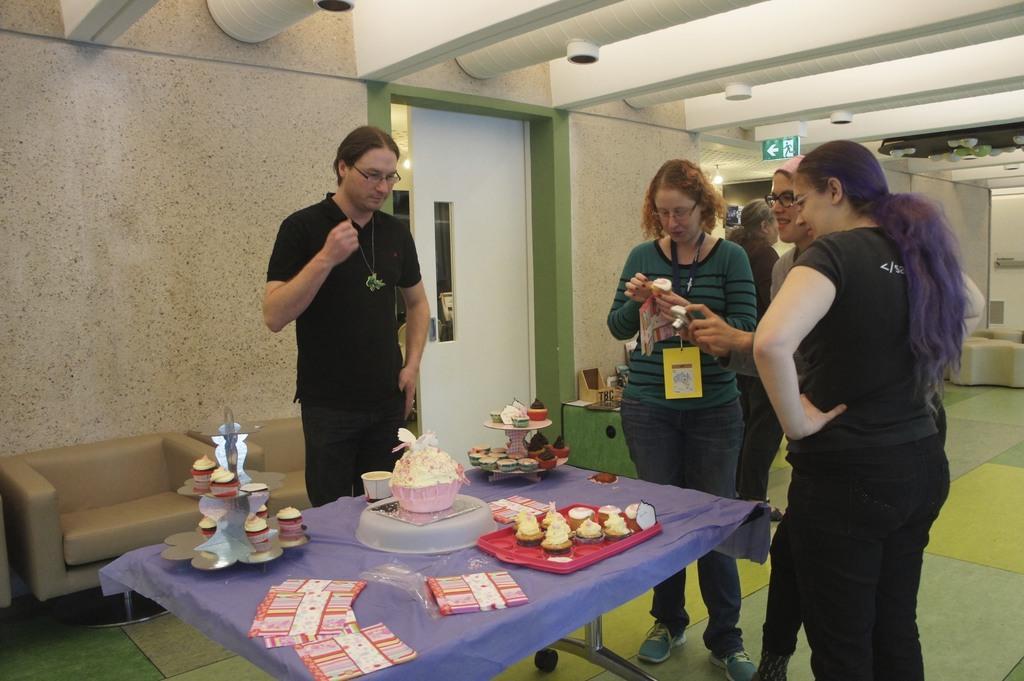In one or two sentences, can you explain what this image depicts? There are four persons standing around a table. A lady in the middle wearing a tag is holding something on her hand. And another lady wearing specs is holding a camera. On the table there are papers, cupcakes, bowl, trays, cups and many other food items. In the background there are two chairs, wall, door, EXIT sign board, and lights are over there. 